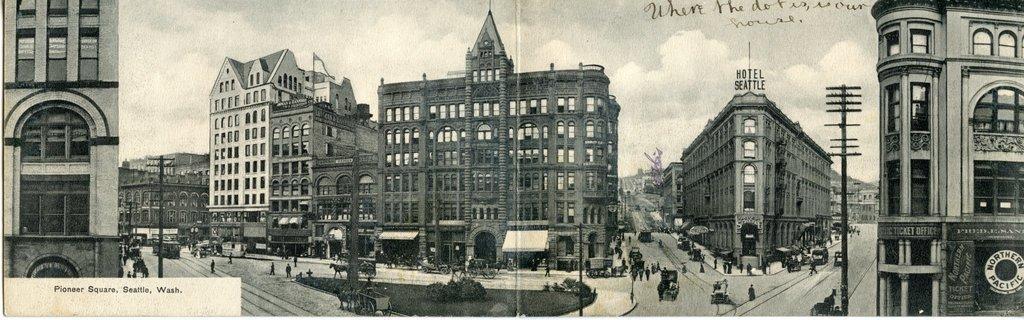How would you summarize this image in a sentence or two? In this picture we can see few buildings, poles, vehicles and group of people, at the top and bottom of the image we can see some text, in the background we can see clouds and it is a black and white photograph. 